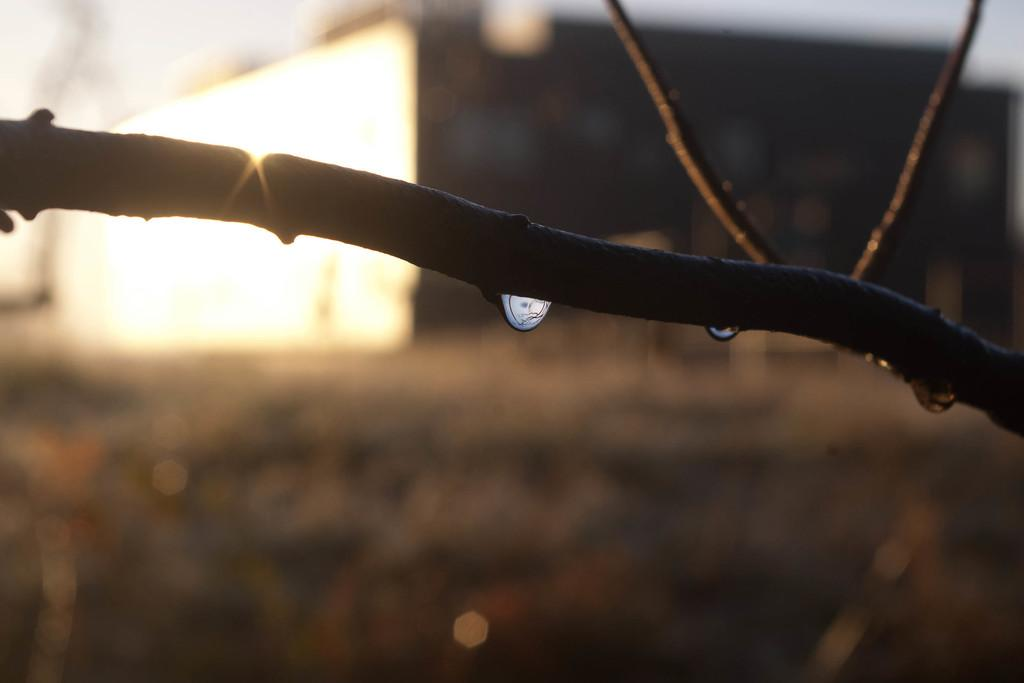What is present on the branch of the tree in the image? There are water drops on the branch of a tree in the image. What can be seen in the distance behind the tree? There is a building visible in the background of the image. What type of watch is the tree wearing in the image? There is no watch present in the image, as trees do not wear watches. 